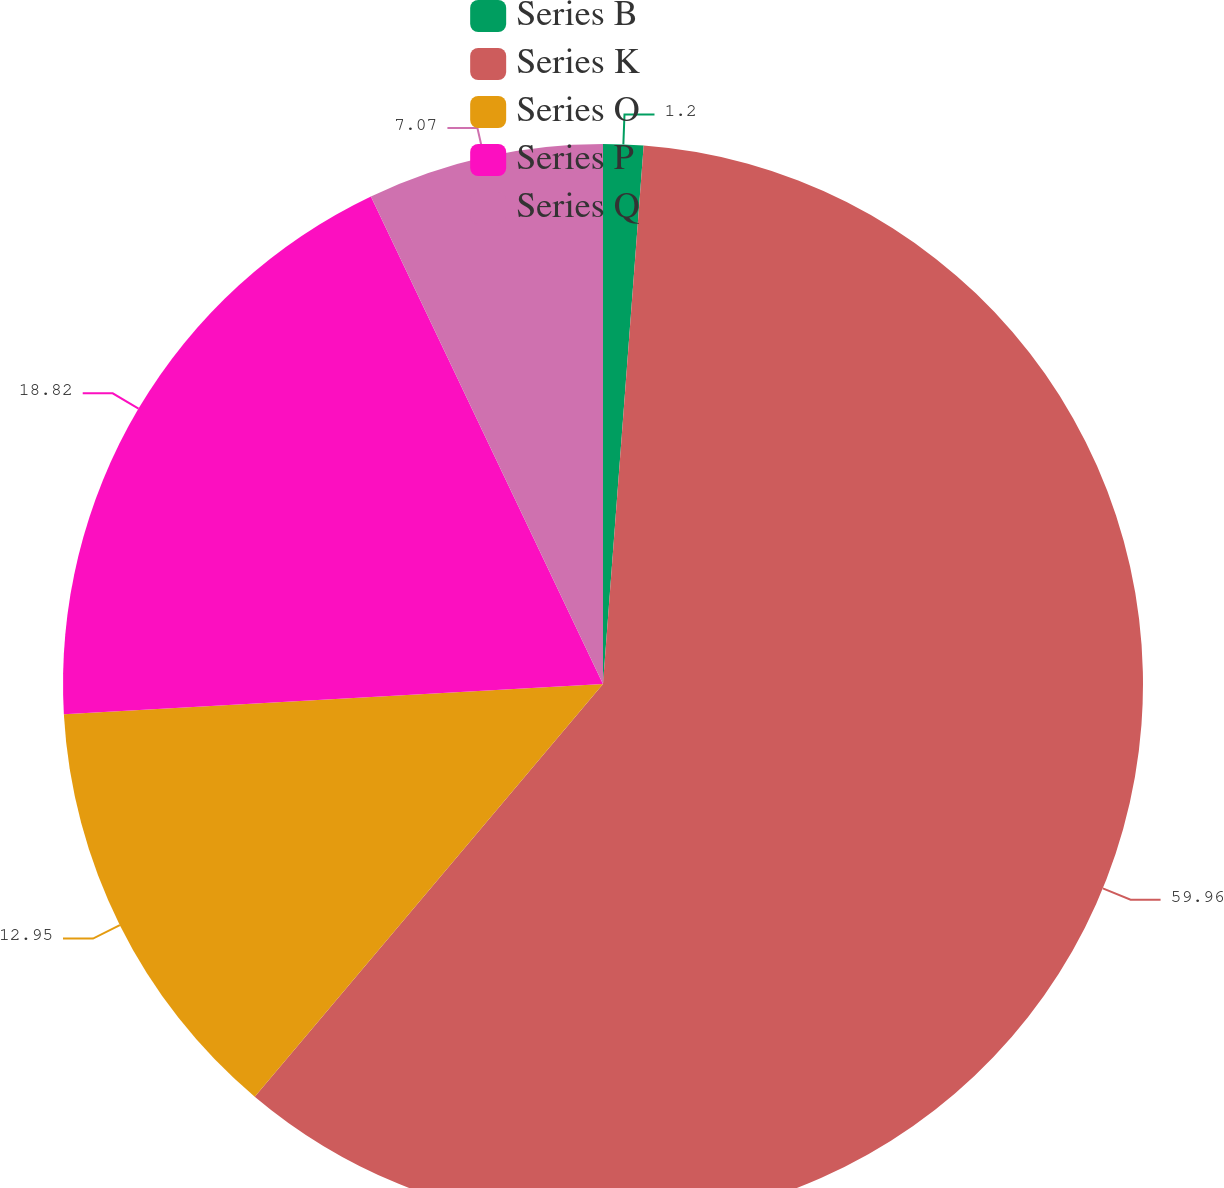Convert chart to OTSL. <chart><loc_0><loc_0><loc_500><loc_500><pie_chart><fcel>Series B<fcel>Series K<fcel>Series O<fcel>Series P<fcel>Series Q<nl><fcel>1.2%<fcel>59.95%<fcel>12.95%<fcel>18.82%<fcel>7.07%<nl></chart> 